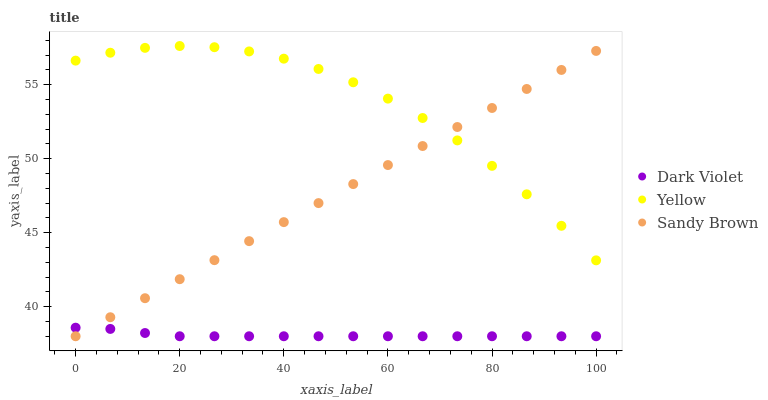Does Dark Violet have the minimum area under the curve?
Answer yes or no. Yes. Does Yellow have the maximum area under the curve?
Answer yes or no. Yes. Does Yellow have the minimum area under the curve?
Answer yes or no. No. Does Dark Violet have the maximum area under the curve?
Answer yes or no. No. Is Sandy Brown the smoothest?
Answer yes or no. Yes. Is Yellow the roughest?
Answer yes or no. Yes. Is Dark Violet the smoothest?
Answer yes or no. No. Is Dark Violet the roughest?
Answer yes or no. No. Does Sandy Brown have the lowest value?
Answer yes or no. Yes. Does Yellow have the lowest value?
Answer yes or no. No. Does Yellow have the highest value?
Answer yes or no. Yes. Does Dark Violet have the highest value?
Answer yes or no. No. Is Dark Violet less than Yellow?
Answer yes or no. Yes. Is Yellow greater than Dark Violet?
Answer yes or no. Yes. Does Dark Violet intersect Sandy Brown?
Answer yes or no. Yes. Is Dark Violet less than Sandy Brown?
Answer yes or no. No. Is Dark Violet greater than Sandy Brown?
Answer yes or no. No. Does Dark Violet intersect Yellow?
Answer yes or no. No. 